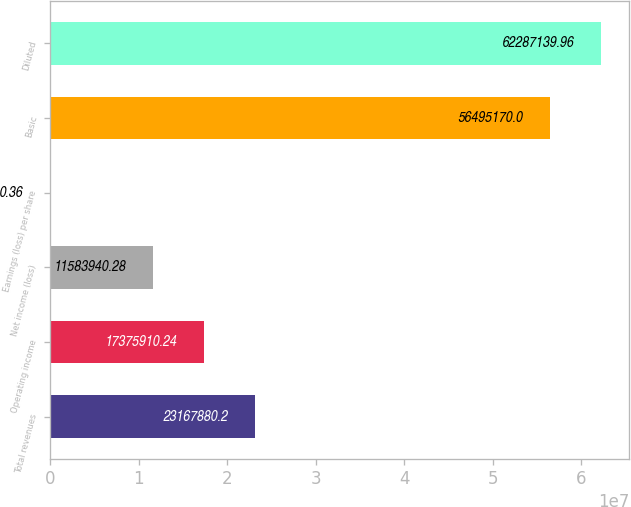Convert chart. <chart><loc_0><loc_0><loc_500><loc_500><bar_chart><fcel>Total revenues<fcel>Operating income<fcel>Net income (loss)<fcel>Earnings (loss) per share<fcel>Basic<fcel>Diluted<nl><fcel>2.31679e+07<fcel>1.73759e+07<fcel>1.15839e+07<fcel>0.36<fcel>5.64952e+07<fcel>6.22871e+07<nl></chart> 